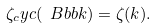<formula> <loc_0><loc_0><loc_500><loc_500>\zeta _ { c } y c ( \ B b b k ) = \zeta ( k ) .</formula> 